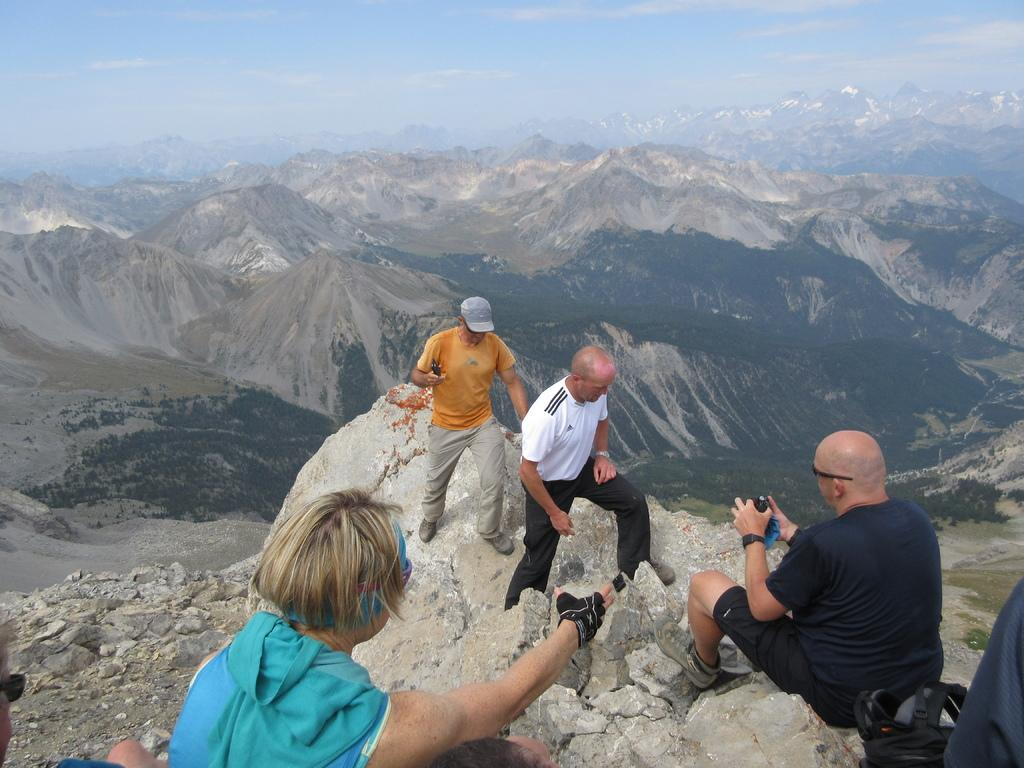What can be seen on the hill in the image? There are people on the hill in the image. What is present on the ground near the hill? There are stones on the ground. What can be seen in the distance behind the hill? There are hills visible in the background. How would you describe the sky in the image? The sky is cloudy in the image. How many horses are present on the hill in the image? There are no horses present on the hill in the image. What type of power source can be seen in the image? There is no power source visible in the image. 